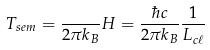<formula> <loc_0><loc_0><loc_500><loc_500>T _ { s e m } = \frac { } { 2 \pi k _ { B } } H = \frac { \hbar { c } } { 2 \pi k _ { B } } \frac { 1 } { L _ { c \ell } }</formula> 